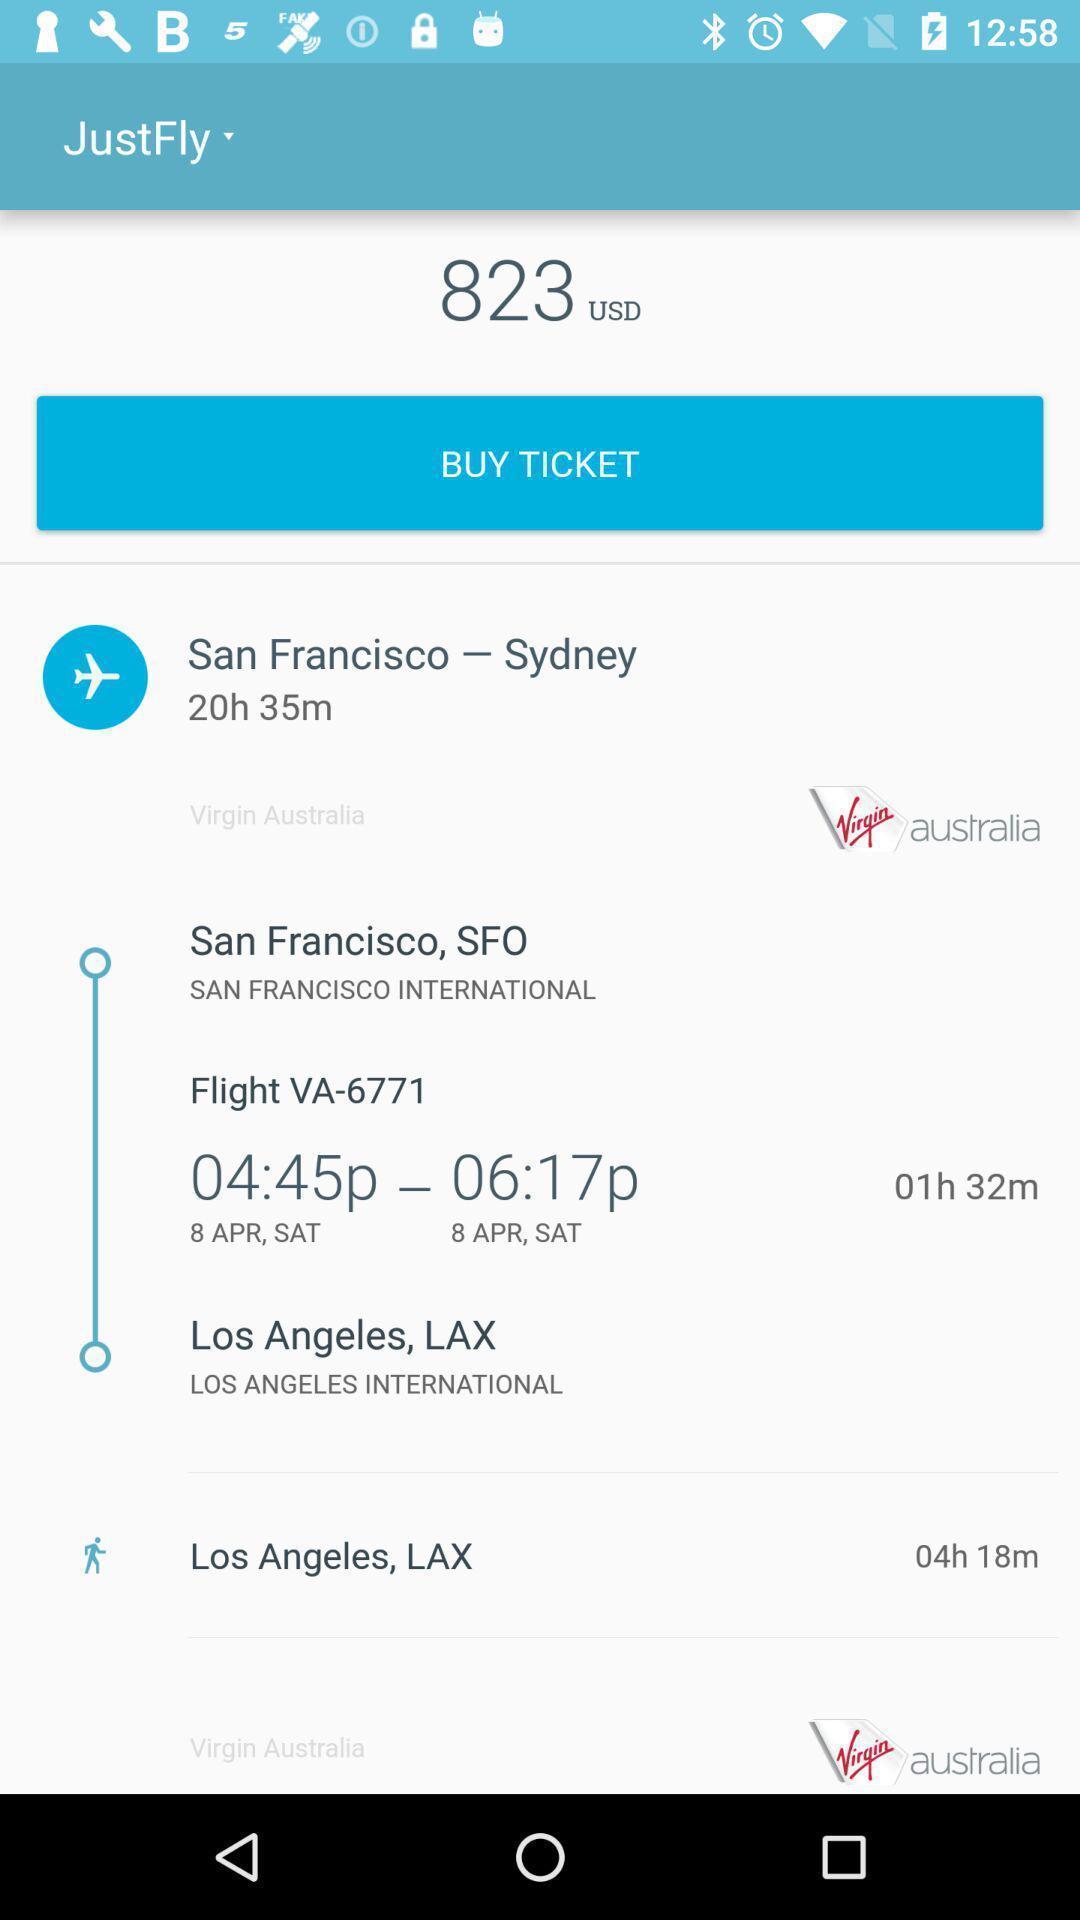Provide a textual representation of this image. Page showing information about flights and tickets prices. 